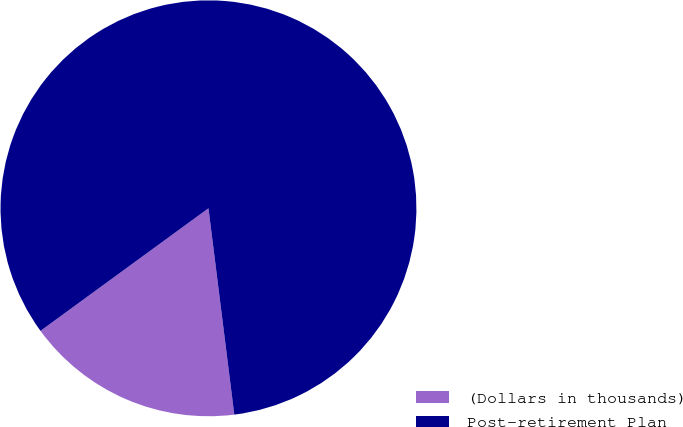<chart> <loc_0><loc_0><loc_500><loc_500><pie_chart><fcel>(Dollars in thousands)<fcel>Post-retirement Plan<nl><fcel>16.95%<fcel>83.05%<nl></chart> 